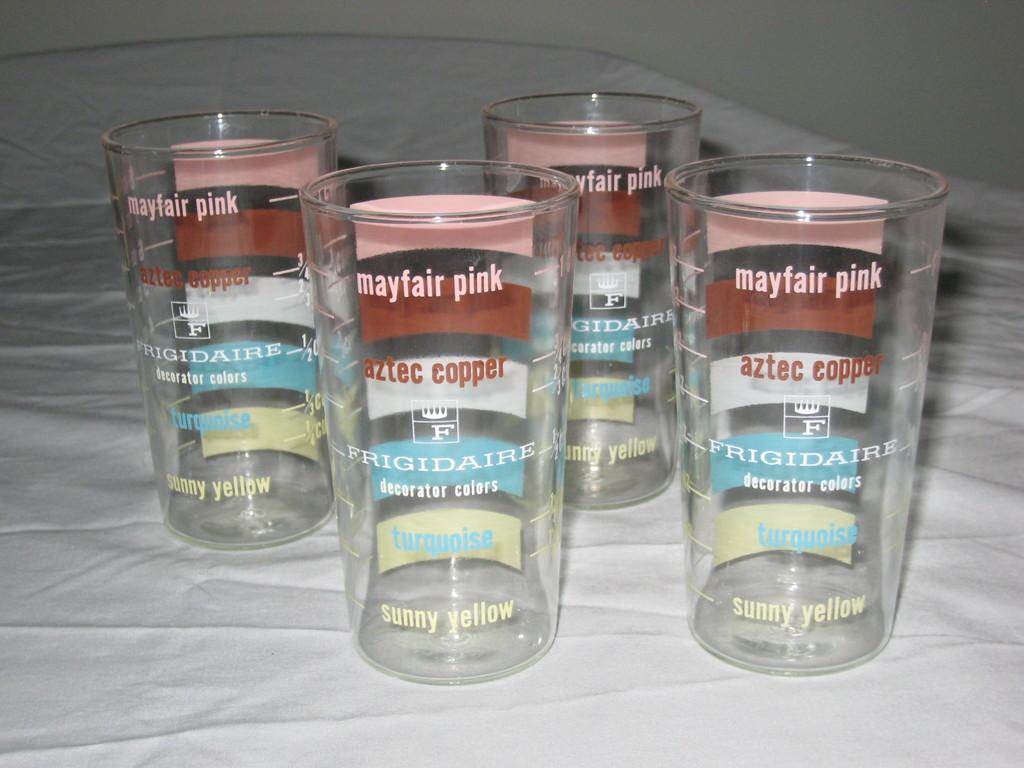What color is mayfair?
Make the answer very short. Pink. What color is sunny?
Your answer should be compact. Yellow. 